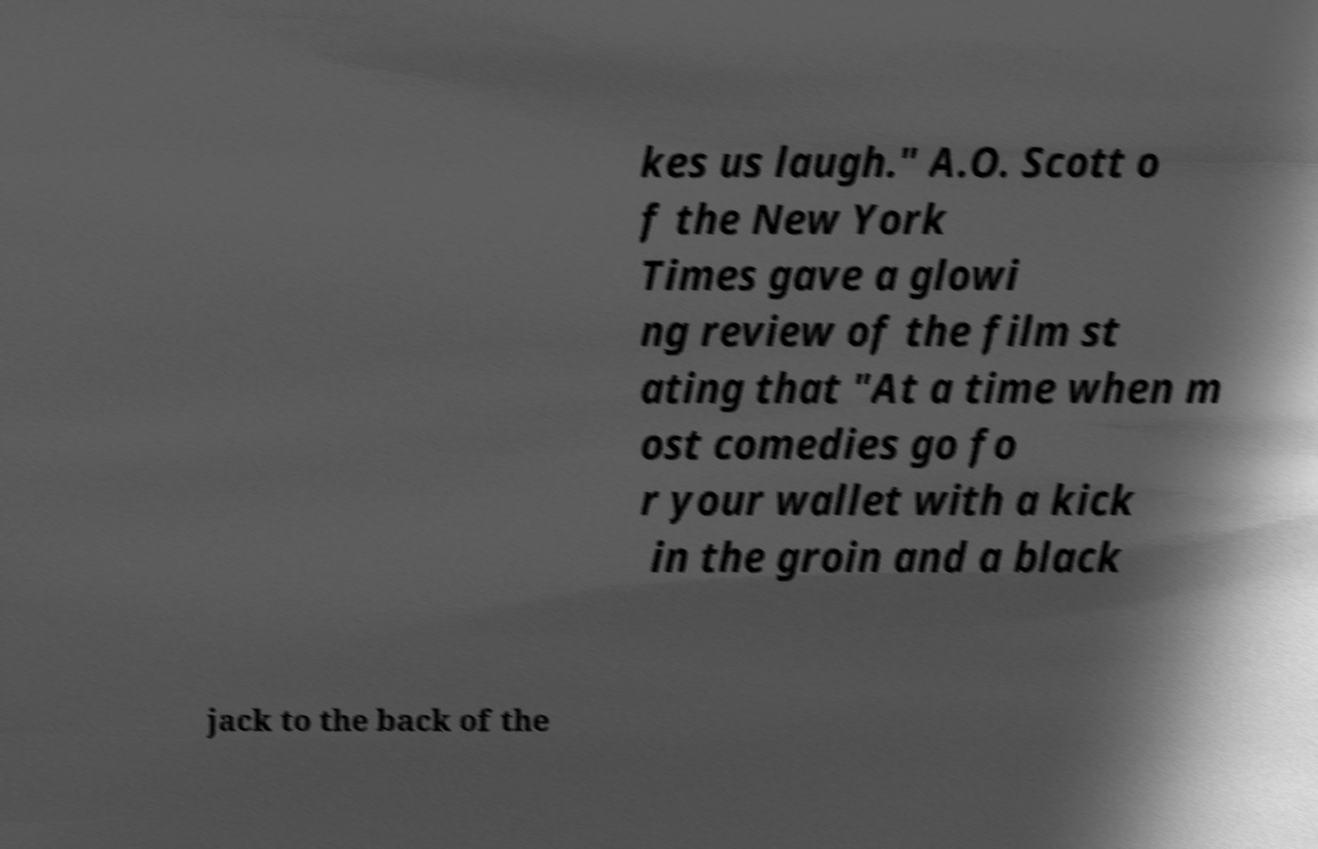Please identify and transcribe the text found in this image. kes us laugh." A.O. Scott o f the New York Times gave a glowi ng review of the film st ating that "At a time when m ost comedies go fo r your wallet with a kick in the groin and a black jack to the back of the 